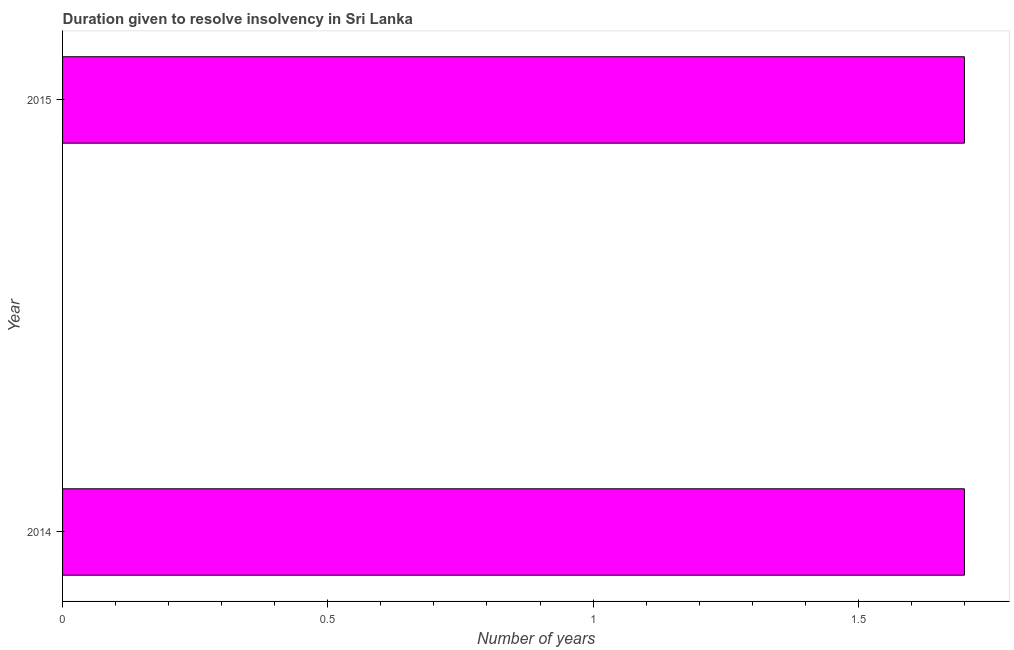Does the graph contain any zero values?
Provide a short and direct response. No. What is the title of the graph?
Your response must be concise. Duration given to resolve insolvency in Sri Lanka. What is the label or title of the X-axis?
Ensure brevity in your answer.  Number of years. In which year was the number of years to resolve insolvency maximum?
Your response must be concise. 2014. What is the difference between the number of years to resolve insolvency in 2014 and 2015?
Keep it short and to the point. 0. What is the average number of years to resolve insolvency per year?
Provide a succinct answer. 1.7. What is the median number of years to resolve insolvency?
Your answer should be very brief. 1.7. In how many years, is the number of years to resolve insolvency greater than 1.2 ?
Your answer should be very brief. 2. Do a majority of the years between 2015 and 2014 (inclusive) have number of years to resolve insolvency greater than 1.1 ?
Keep it short and to the point. No. Is the number of years to resolve insolvency in 2014 less than that in 2015?
Your response must be concise. No. In how many years, is the number of years to resolve insolvency greater than the average number of years to resolve insolvency taken over all years?
Ensure brevity in your answer.  0. How many years are there in the graph?
Provide a succinct answer. 2. What is the difference between two consecutive major ticks on the X-axis?
Keep it short and to the point. 0.5. What is the Number of years of 2014?
Keep it short and to the point. 1.7. What is the Number of years in 2015?
Your answer should be compact. 1.7. What is the difference between the Number of years in 2014 and 2015?
Provide a short and direct response. 0. What is the ratio of the Number of years in 2014 to that in 2015?
Provide a succinct answer. 1. 